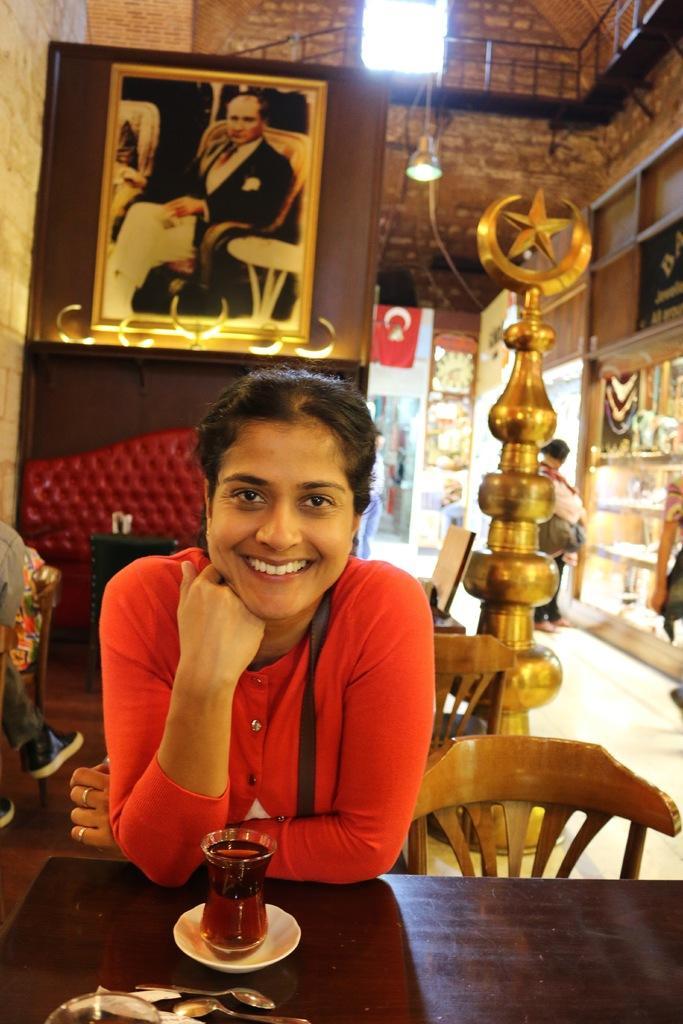Describe this image in one or two sentences. In the image we can see there is woman who is sitting in front of the table and there is a glass filled with a juice and there are lot of spoons in front of her. 